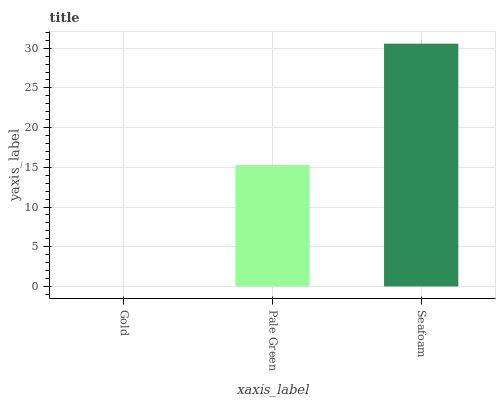Is Gold the minimum?
Answer yes or no. Yes. Is Seafoam the maximum?
Answer yes or no. Yes. Is Pale Green the minimum?
Answer yes or no. No. Is Pale Green the maximum?
Answer yes or no. No. Is Pale Green greater than Gold?
Answer yes or no. Yes. Is Gold less than Pale Green?
Answer yes or no. Yes. Is Gold greater than Pale Green?
Answer yes or no. No. Is Pale Green less than Gold?
Answer yes or no. No. Is Pale Green the high median?
Answer yes or no. Yes. Is Pale Green the low median?
Answer yes or no. Yes. Is Gold the high median?
Answer yes or no. No. Is Gold the low median?
Answer yes or no. No. 